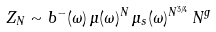Convert formula to latex. <formula><loc_0><loc_0><loc_500><loc_500>Z _ { N } \sim b ^ { - } ( \omega ) \, \mu ( \omega ) ^ { N } \, \mu _ { s } ( \omega ) ^ { N ^ { 3 / 4 } } \, N ^ { g }</formula> 